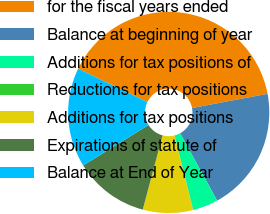Convert chart. <chart><loc_0><loc_0><loc_500><loc_500><pie_chart><fcel>for the fiscal years ended<fcel>Balance at beginning of year<fcel>Additions for tax positions of<fcel>Reductions for tax positions<fcel>Additions for tax positions<fcel>Expirations of statute of<fcel>Balance at End of Year<nl><fcel>39.88%<fcel>19.97%<fcel>4.05%<fcel>0.07%<fcel>8.03%<fcel>12.01%<fcel>15.99%<nl></chart> 